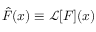Convert formula to latex. <formula><loc_0><loc_0><loc_500><loc_500>{ \hat { F } } ( x ) \equiv \mathcal { L } [ F ] ( x )</formula> 